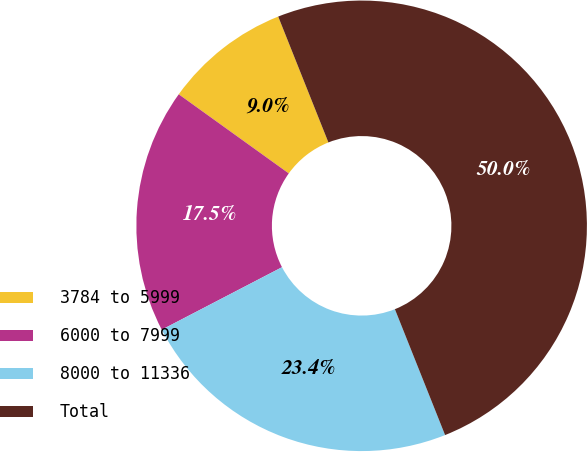<chart> <loc_0><loc_0><loc_500><loc_500><pie_chart><fcel>3784 to 5999<fcel>6000 to 7999<fcel>8000 to 11336<fcel>Total<nl><fcel>9.04%<fcel>17.55%<fcel>23.41%<fcel>50.0%<nl></chart> 